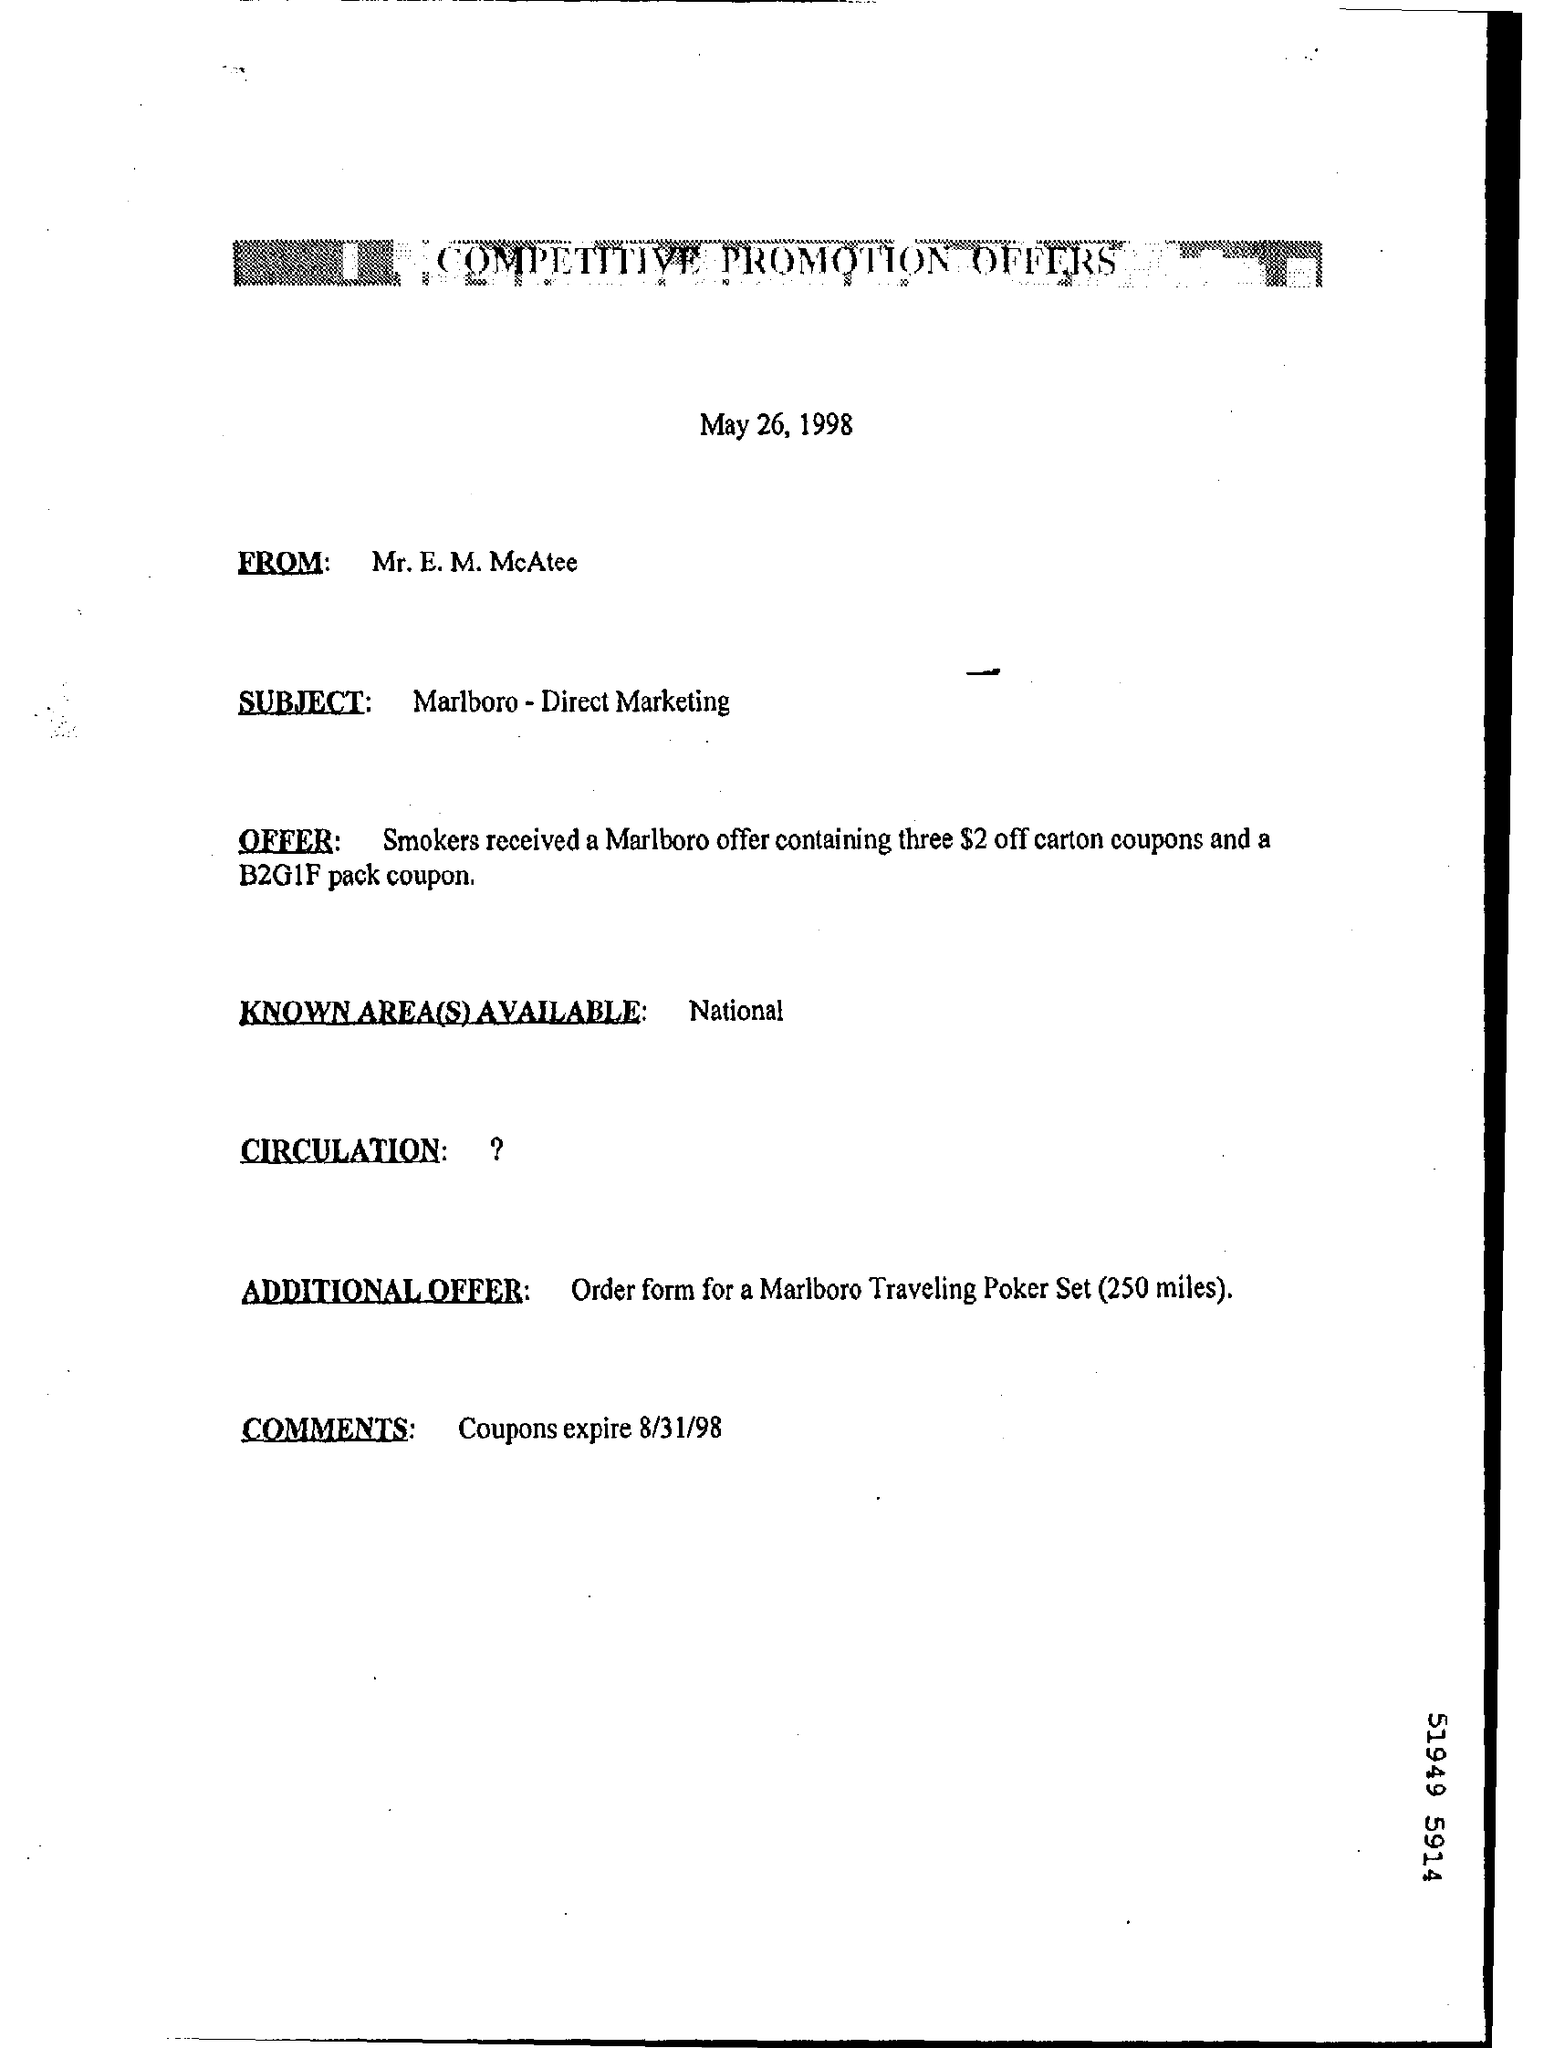When is the document dated?
Give a very brief answer. May 26, 1998. Which is the known area(s) available?
Offer a very short reply. National. When will the coupons expire?
Your answer should be compact. 8/31/98. 